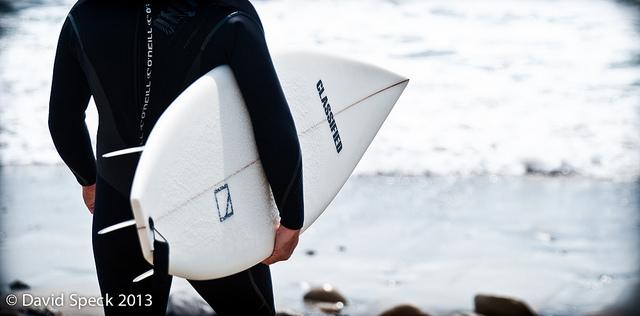Is the surfboard horizontal or vertical?
Keep it brief. Horizontal. What color is the surfboard?
Quick response, please. White. Whose surfboard is that?
Quick response, please. David speck. Is the surfer's head visible in this photo?
Write a very short answer. No. 